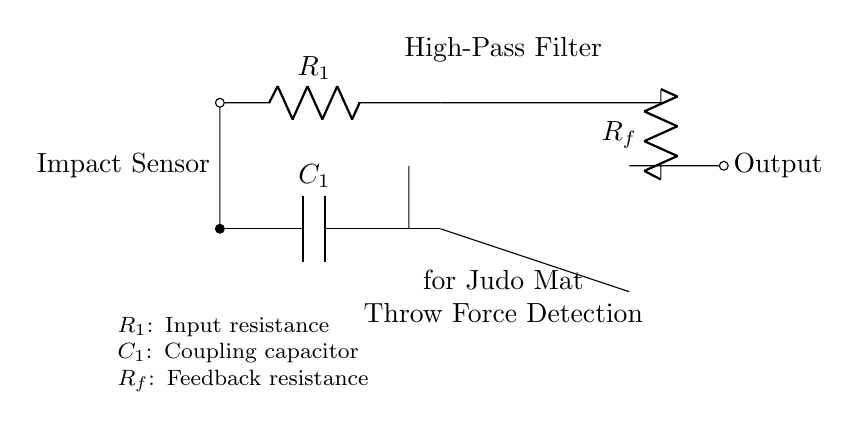What is the role of R1 in the circuit? R1 acts as the input resistance to the high-pass filter, limiting the current that can enter the circuit from the impact sensor.
Answer: Input resistance What type of filter is represented in the circuit? The circuit diagram represents a high-pass filter, which allows high-frequency signals to pass through while attenuating low-frequency signals, making it ideal for detecting throw force.
Answer: High-pass filter What does C1 represent in this circuit? C1 is the coupling capacitor, which blocks any DC component of the input signal and allows AC signals above a certain frequency to pass through to the operational amplifier.
Answer: Coupling capacitor What is the purpose of the operational amplifier in the circuit? The operational amplifier amplifies the filtered signals from the high-pass filter to provide a stronger output signal that can be used for further processing or analysis.
Answer: Amplify How does the feedback resistor Rf affect the circuit's function? The feedback resistor Rf determines the gain of the operational amplifier, allowing the designer to set a specific level of signal amplification based on the desired output for the detected throw force.
Answer: Determines gain What happens to low-frequency signals in this circuit? Low-frequency signals are attenuated because they do not pass through the high-pass filter, ensuring that only higher frequency signals related to impacts are detected and amplified.
Answer: Attenuated 